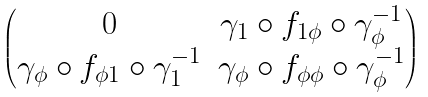Convert formula to latex. <formula><loc_0><loc_0><loc_500><loc_500>\begin{pmatrix} 0 & \gamma _ { 1 } \circ f _ { 1 \phi } \circ \gamma _ { \phi } ^ { - 1 } \\ \gamma _ { \phi } \circ f _ { \phi 1 } \circ \gamma _ { 1 } ^ { - 1 } & \gamma _ { \phi } \circ f _ { \phi \phi } \circ \gamma _ { \phi } ^ { - 1 } \end{pmatrix}</formula> 